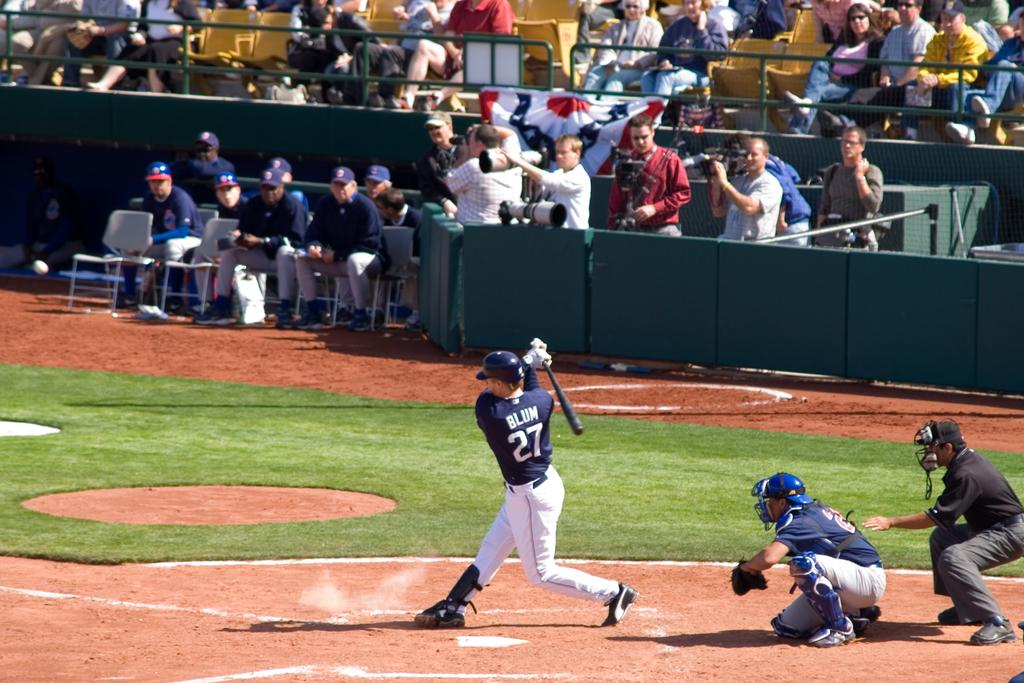<image>
Present a compact description of the photo's key features. A player wearing a navy jersey with the number 27 swings his bat 